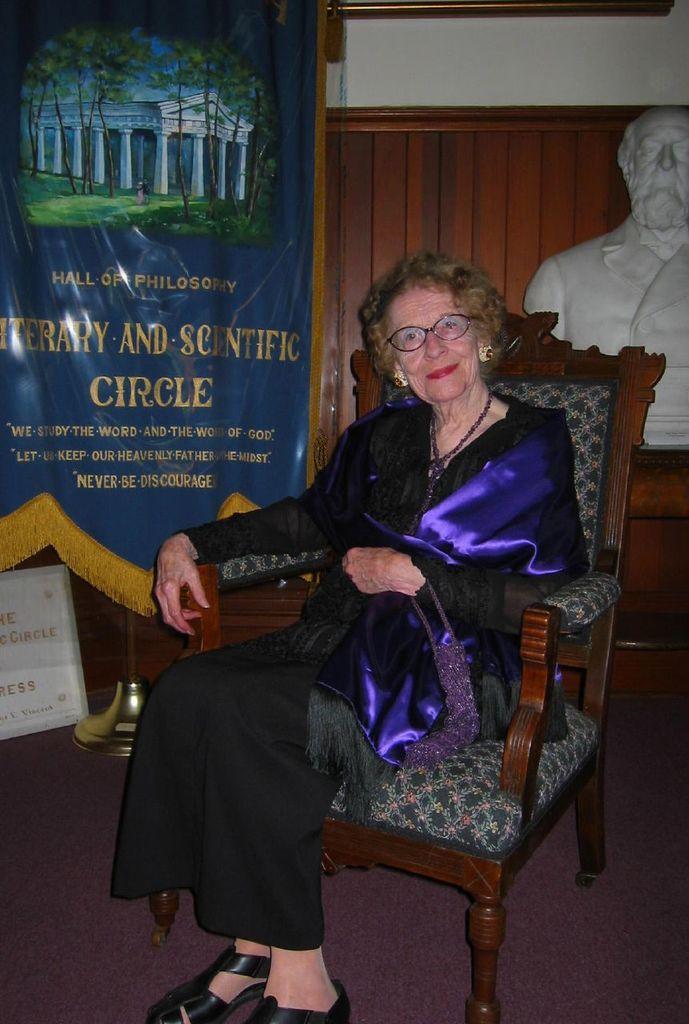How would you summarize this image in a sentence or two? This picture describes about a woman seated on the chair in the background we can see a statue and a hoarding. 